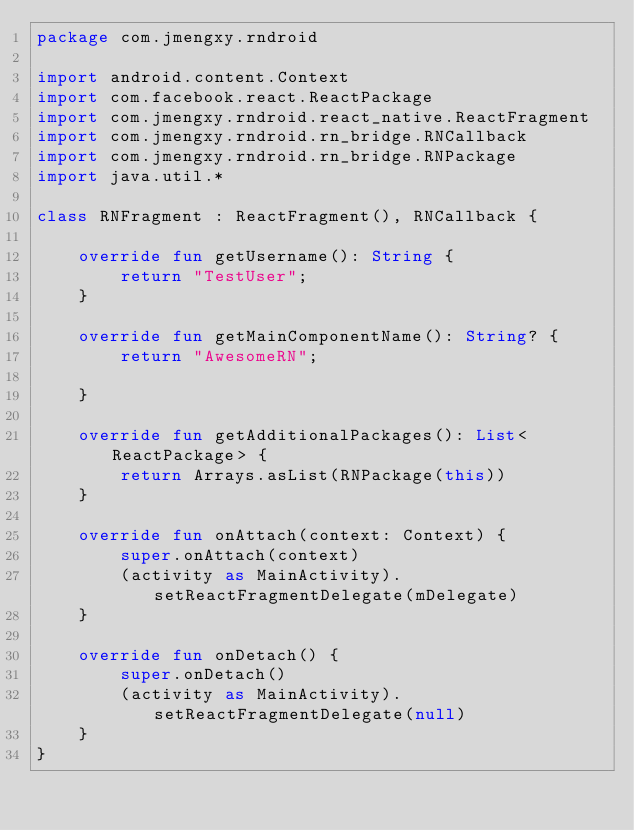<code> <loc_0><loc_0><loc_500><loc_500><_Kotlin_>package com.jmengxy.rndroid

import android.content.Context
import com.facebook.react.ReactPackage
import com.jmengxy.rndroid.react_native.ReactFragment
import com.jmengxy.rndroid.rn_bridge.RNCallback
import com.jmengxy.rndroid.rn_bridge.RNPackage
import java.util.*

class RNFragment : ReactFragment(), RNCallback {

    override fun getUsername(): String {
        return "TestUser";
    }

    override fun getMainComponentName(): String? {
        return "AwesomeRN";

    }

    override fun getAdditionalPackages(): List<ReactPackage> {
        return Arrays.asList(RNPackage(this))
    }

    override fun onAttach(context: Context) {
        super.onAttach(context)
        (activity as MainActivity).setReactFragmentDelegate(mDelegate)
    }

    override fun onDetach() {
        super.onDetach()
        (activity as MainActivity).setReactFragmentDelegate(null)
    }
}</code> 